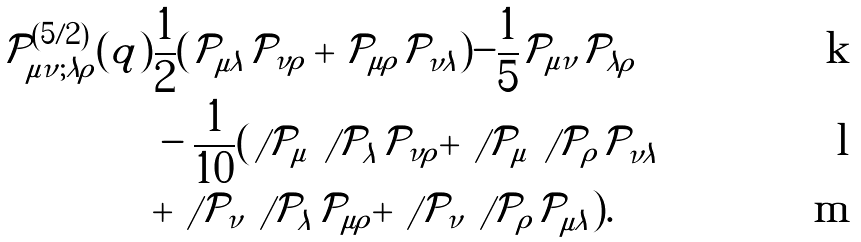Convert formula to latex. <formula><loc_0><loc_0><loc_500><loc_500>\mathcal { P } _ { \mu \nu ; \lambda \rho } ^ { ( 5 / 2 ) } ( q ) & \frac { 1 } { 2 } ( \mathcal { P } _ { \mu \lambda } \mathcal { P } _ { \nu \rho } + \mathcal { P } _ { \mu \rho } \mathcal { P } _ { \nu \lambda } ) - \frac { 1 } { 5 } \mathcal { P } _ { \mu \nu } \mathcal { P } _ { \lambda \rho } \\ & - \frac { 1 } { 1 0 } ( \not \, \mathcal { P } _ { \mu } \not \, \mathcal { P } _ { \lambda } \mathcal { P } _ { \nu \rho } + \not \, \mathcal { P } _ { \mu } \not \, \mathcal { P } _ { \rho } \mathcal { P } _ { \nu \lambda } \\ & + \not \, \mathcal { P } _ { \nu } \not \, \mathcal { P } _ { \lambda } \mathcal { P } _ { \mu \rho } + \not \, \mathcal { P } _ { \nu } \not \, \mathcal { P } _ { \rho } \mathcal { P } _ { \mu \lambda } ) .</formula> 